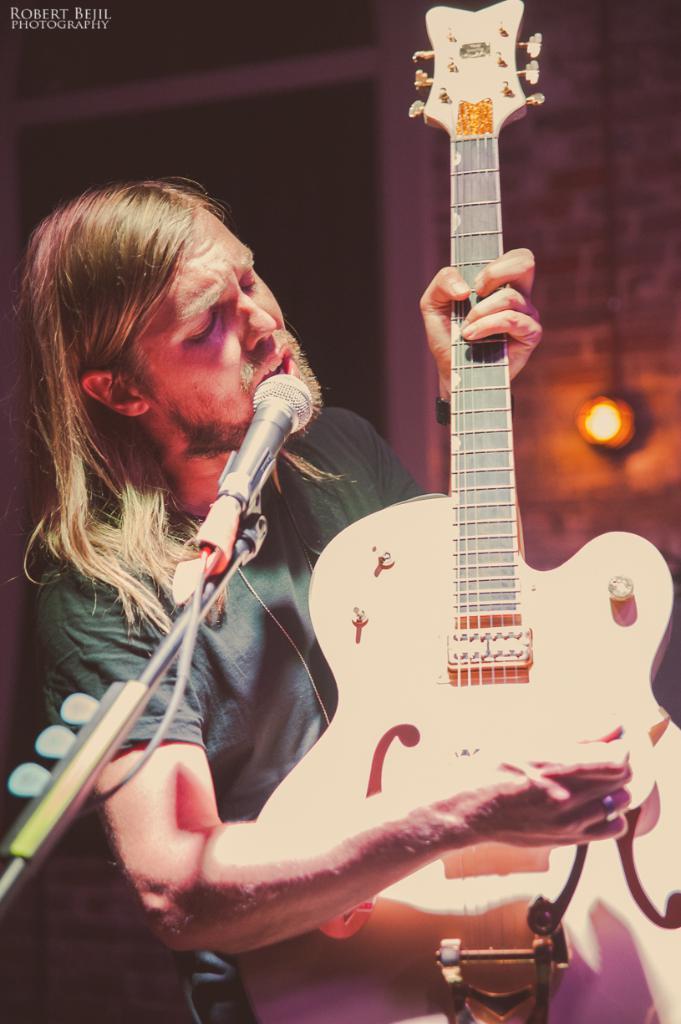In one or two sentences, can you explain what this image depicts? The picture is taken inside a room. A man who is wearing a green t shirt is playing guitar along with singing song. in front of him there is mic. In the background there is wall. On the wall there is light. 